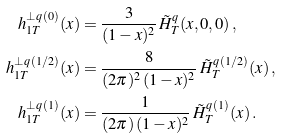<formula> <loc_0><loc_0><loc_500><loc_500>h _ { 1 T } ^ { \bot q \, ( 0 ) } ( x ) & = \frac { 3 } { ( 1 - x ) ^ { 2 } } \, \tilde { H } _ { T } ^ { q } ( x , 0 , 0 ) \, , \\ h _ { 1 T } ^ { \bot q \, ( 1 / 2 ) } ( x ) & = \frac { 8 } { ( 2 \pi ) ^ { 2 } \, ( 1 - x ) ^ { 2 } } \, \tilde { H } _ { T } ^ { q \, ( 1 / 2 ) } ( x ) \, , \\ h _ { 1 T } ^ { \bot q \, ( 1 ) } ( x ) & = \frac { 1 } { ( 2 \pi ) \, ( 1 - x ) ^ { 2 } } \, \tilde { H } _ { T } ^ { q \, ( 1 ) } ( x ) \, .</formula> 